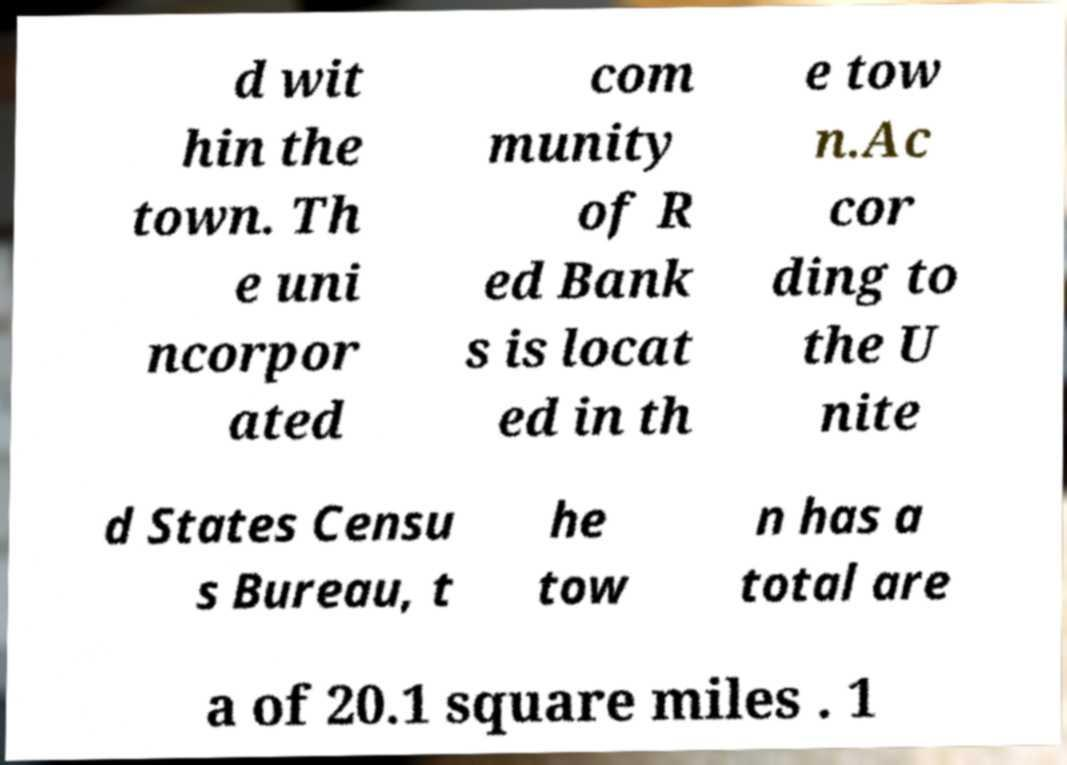Could you assist in decoding the text presented in this image and type it out clearly? d wit hin the town. Th e uni ncorpor ated com munity of R ed Bank s is locat ed in th e tow n.Ac cor ding to the U nite d States Censu s Bureau, t he tow n has a total are a of 20.1 square miles . 1 